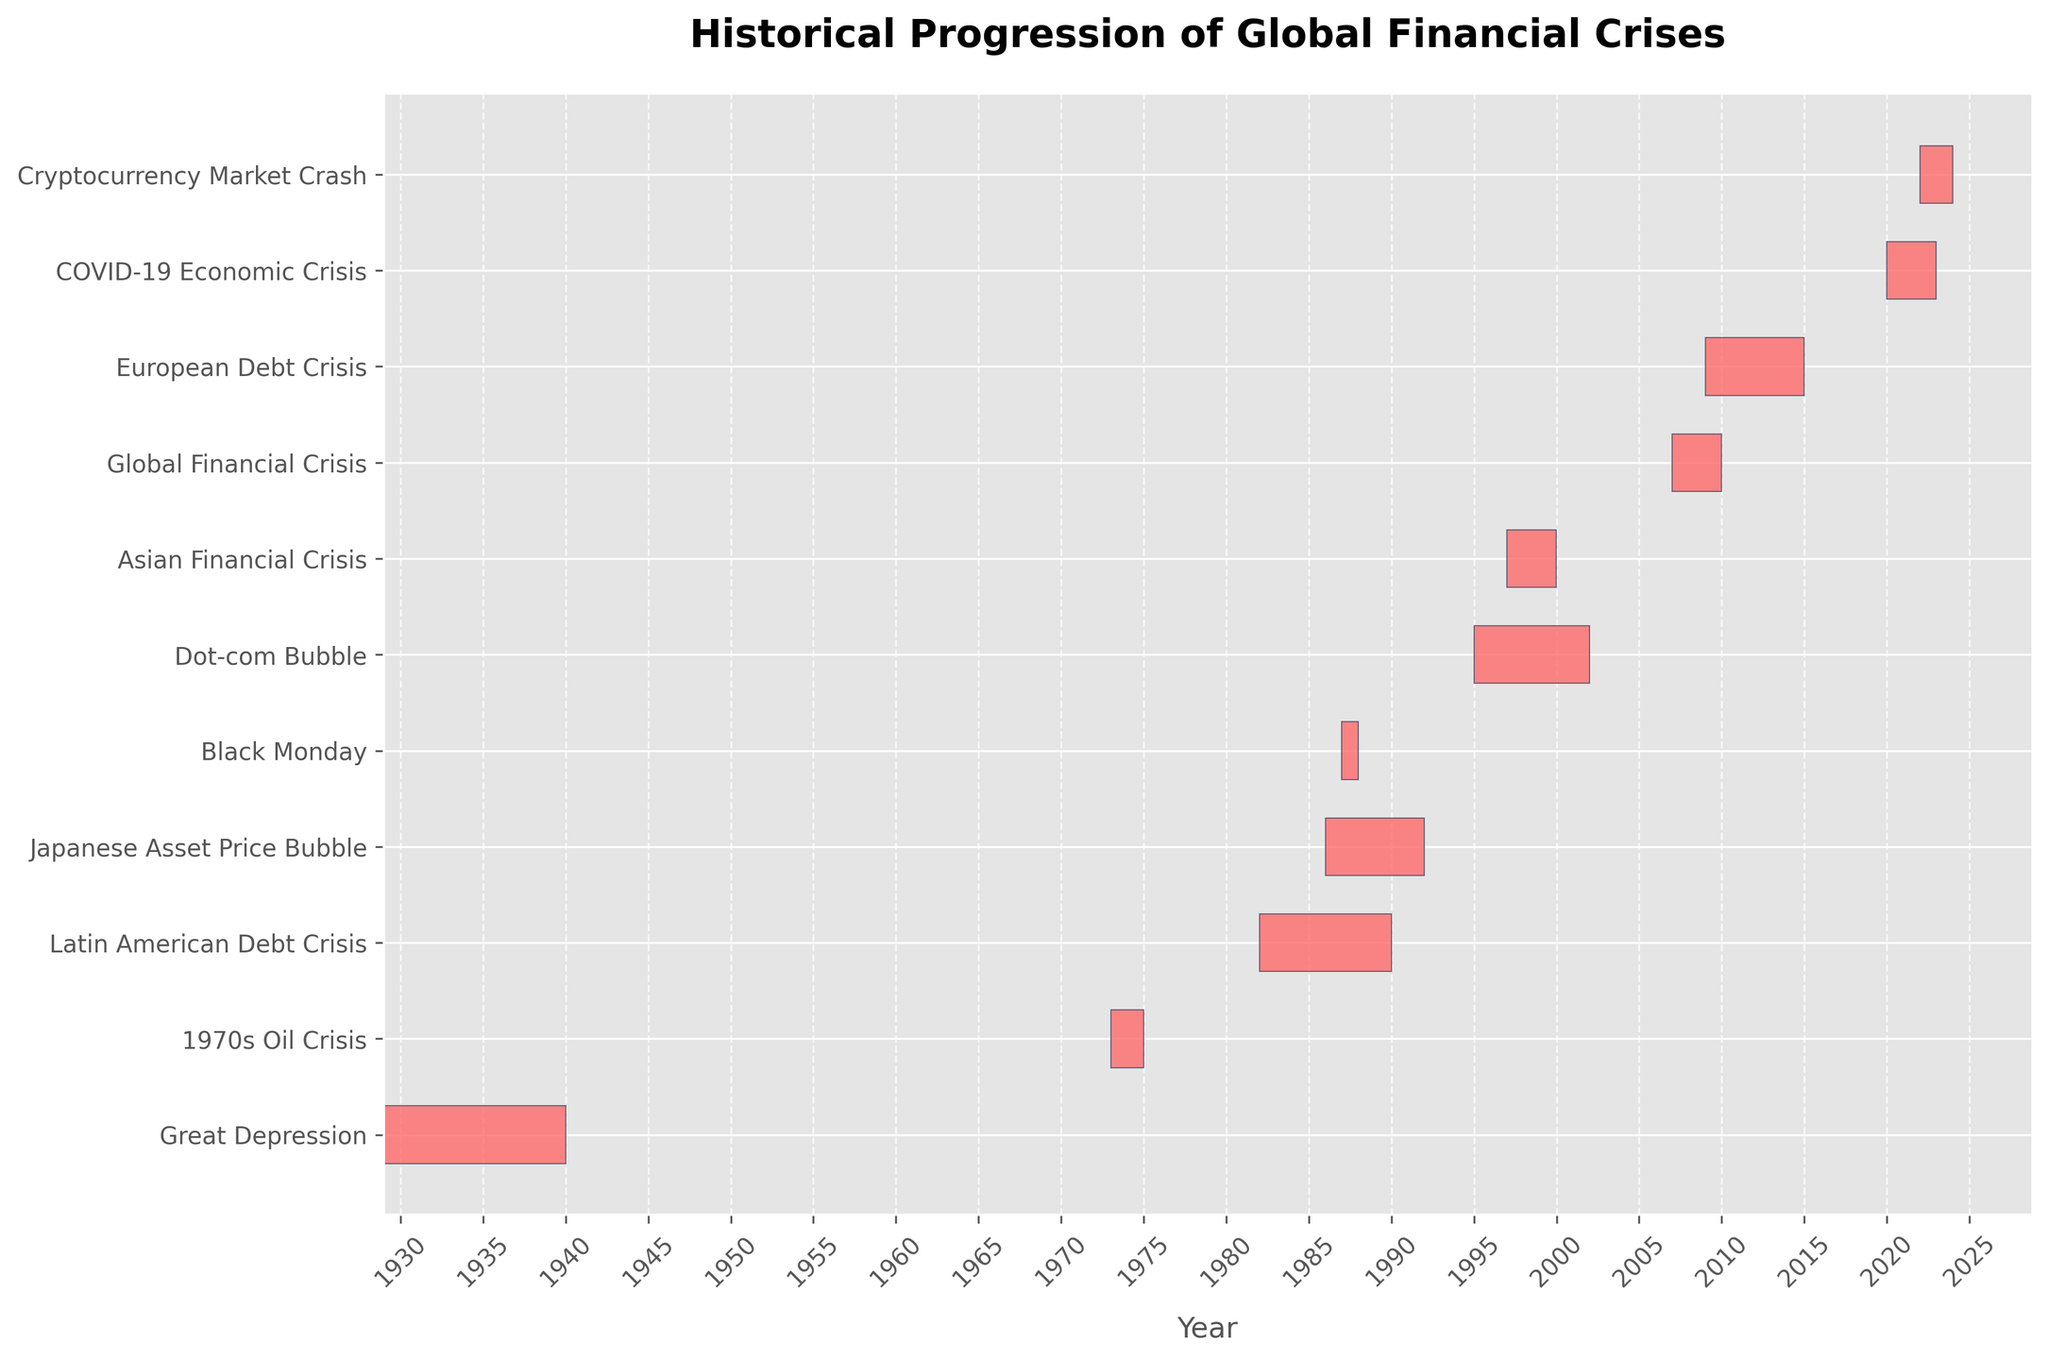What is the title of the Gantt chart? The title of the chart is displayed at the top and provides a summary of what the chart is about. The title reads "Historical Progression of Global Financial Crises".
Answer: Historical Progression of Global Financial Crises Which financial crisis had the longest duration? To determine the longest duration, compare the start and end dates for each financial crisis. The European Debt Crisis lasted from 2009 to 2014, totaling 6 years, being the longest duration in the chart.
Answer: European Debt Crisis How many financial crises occurred before the year 2000? Count all the financial crises that have a start date before the year 2000. These are:
1. Great Depression
2. 1970s Oil Crisis
3. Latin American Debt Crisis
4. Black Monday
5. Japanese Asset Price Bubble
6. Asian Financial Crisis
7. Dot-com Bubble. There are 7 crises.
Answer: 7 Which crisis had the shortest duration? Find the crisis with the smallest difference between the start and end dates. Black Monday, which occurred in 1987, lasted only a year.
Answer: Black Monday How many years did the Dot-com Bubble last? Calculate the difference between the start (1995) and end (2001) dates of the Dot-com Bubble. 2001 - 1995 = 6 years.
Answer: 6 years Which crises overlapped in the 1980s? Identify the crises with periods that overlap in the 1980s. The Latin American Debt Crisis (1982-1989) and Japanese Asset Price Bubble (1986-1991) both overlap with the 1980s.
Answer: Latin American Debt Crisis and Japanese Asset Price Bubble Which crisis started immediately after the Global Financial Crisis? After the Global Financial Crisis (2007-2009), check the next sequential crisis start date. The next one is the European Debt Crisis, starting in 2009.
Answer: European Debt Crisis Did the Dot-com Bubble and the Japanese Asset Price Bubble overlap? Compare the periods of both crises. The Dot-com Bubble (1995-2001) and Japanese Asset Price Bubble (1986-1991) do not overlap.
Answer: No Which crisis followed the 1970s Oil Crisis? The 1970s Oil Crisis occurred from 1973 to 1974. The next crisis in sequence is the Latin American Debt Crisis, starting in 1982.
Answer: Latin American Debt Crisis How long did the COVID-19 Economic Crisis last? Determine the difference between the start (2020) and end (2022) dates of the COVID-19 Economic Crisis. 2022 - 2020 = 2 years.
Answer: 2 years 